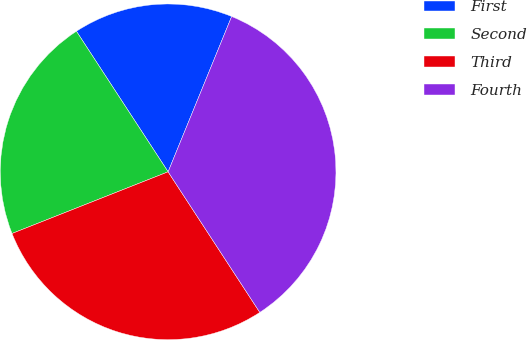<chart> <loc_0><loc_0><loc_500><loc_500><pie_chart><fcel>First<fcel>Second<fcel>Third<fcel>Fourth<nl><fcel>15.38%<fcel>21.79%<fcel>28.21%<fcel>34.62%<nl></chart> 